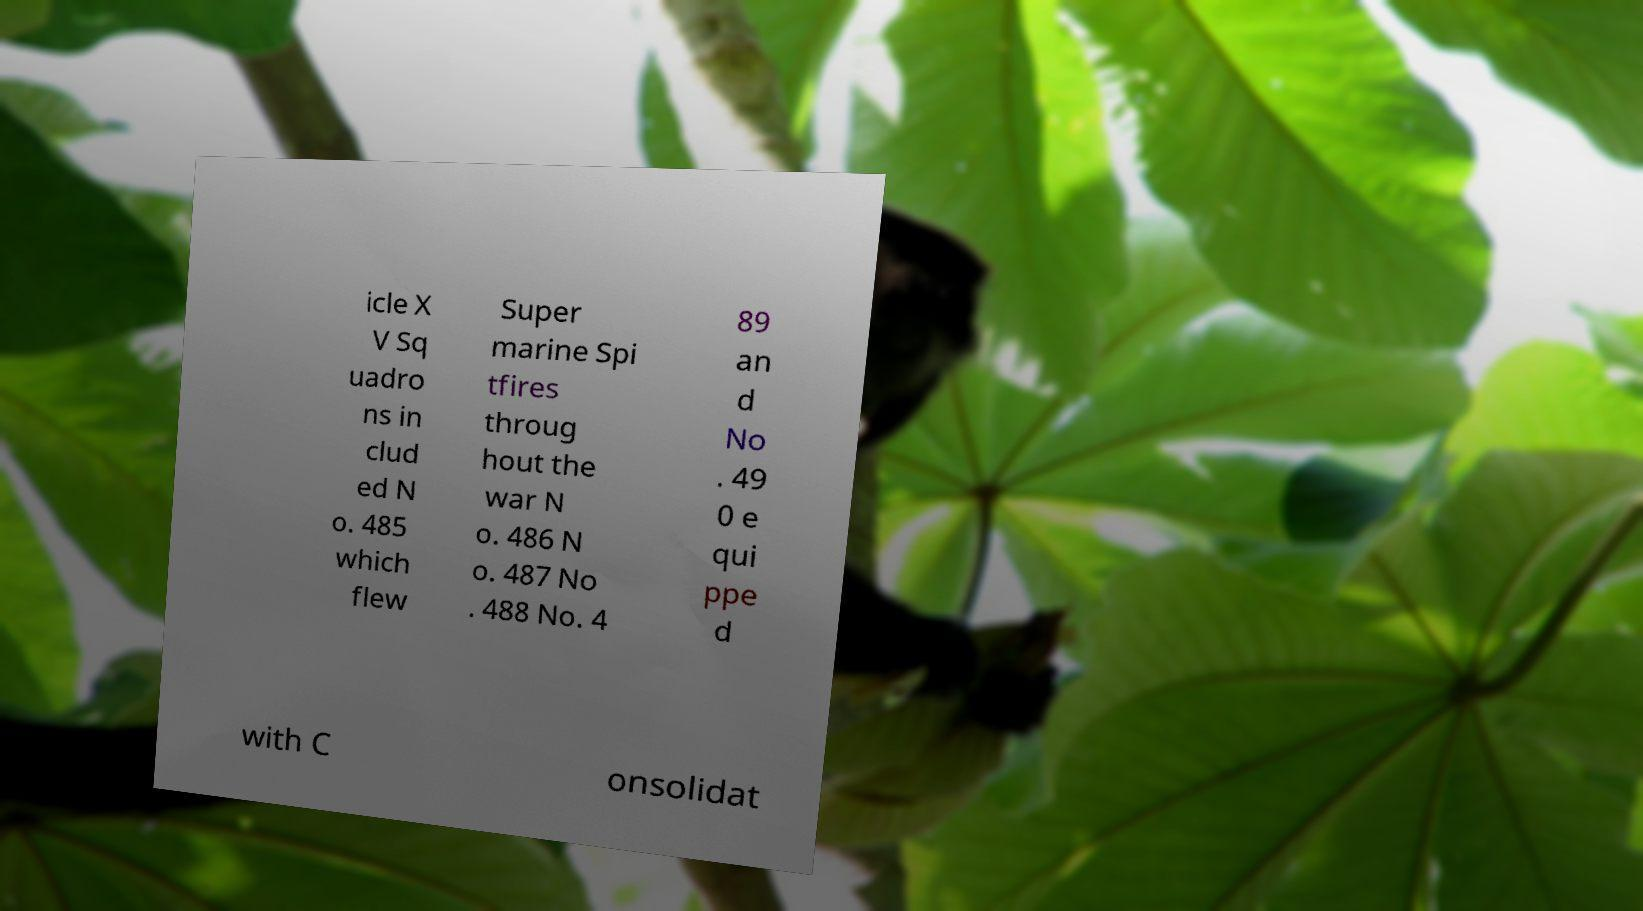Please read and relay the text visible in this image. What does it say? icle X V Sq uadro ns in clud ed N o. 485 which flew Super marine Spi tfires throug hout the war N o. 486 N o. 487 No . 488 No. 4 89 an d No . 49 0 e qui ppe d with C onsolidat 